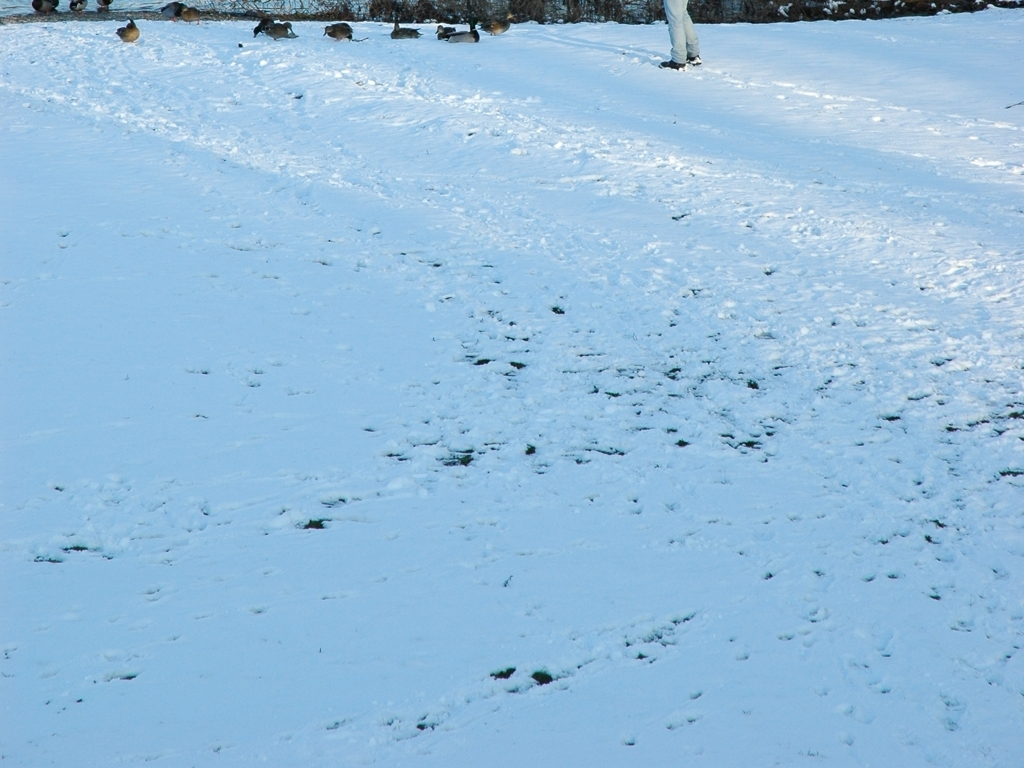Could this image be used to study the effects of winter weather on a particular environment? Definitely. This image provides a snapshot of the environment during winter and can offer insights into how snow cover affects terrain, animal behavior, and vegetation. Scientists and ecologists could use such images to observe patterns and make comparisons over time. 